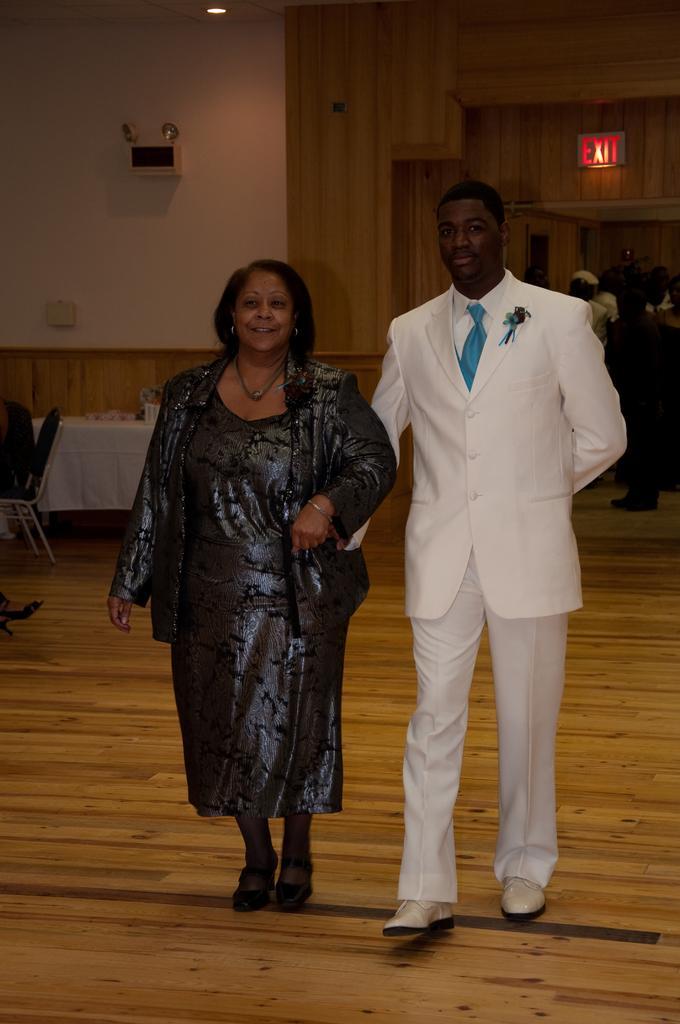In one or two sentences, can you explain what this image depicts? In the center of the image we can see two persons are in different costumes. And we can see they are smiling. In the background there is a wall, light, table, chair, few people and a few other objects. 